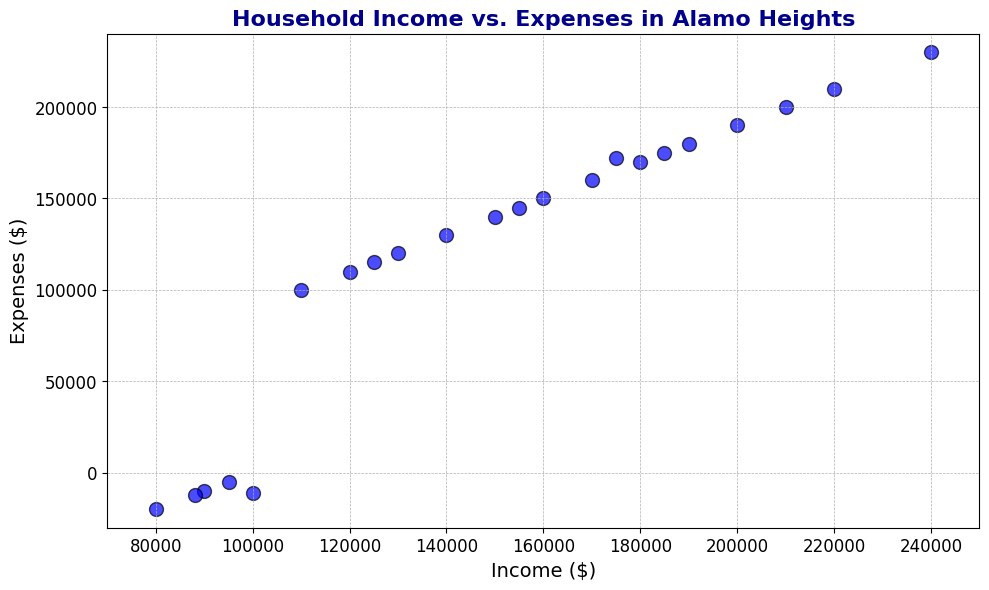What is the highest household income shown in the figure? Locate the data point with the highest value on the x-axis (Income). The largest income shown is at $240,000.
Answer: $240,000 How many data points show negative household expenses? Count the number of points below the x-axis (where Expenses are negative). There are 5 points below the x-axis.
Answer: 5 Which household income has expenses closest to zero? Identify the point closest to the horizontal axis (where Expenses are near zero). The closest point is where Income is $95,000 and Expenses are -$5,000.
Answer: $95,000 What is the average household income of the families with negative expenses? Summing the incomes of families with negative expenses (90,000, 80,000, 95,000, 88,000, 100,000) and dividing by the number of such families (5): (90,000 + 80,000 + 95,000 + 88,000 + 100,000) / 5 = $90,600
Answer: $90,600 Which household income has the highest expenses? Locate the data point with the highest value on the y-axis (Expenses). The highest expenses shown are at $230,000 corresponding to an income of $240,000.
Answer: $240,000 Compare the household incomes and expenses of the family with the highest income and the family with the lowest income. The family with the highest income ($240,000) has expenses of $230,000. The family with the lowest income ($80,000) has expenses of -$20,000.
Answer: $240,000 income/$230,000 expenses vs. $80,000 income/$-20,000 expenses What is the range of expenses for families earning between $150,000 and $180,000? Identify the data points with incomes in the range. The expenses range from $140,000 to $175,000 for incomes between $150,000 and $180,000.
Answer: $140,000 to $175,000 Is there a family with an income of $100,000? If so, what are their expenses? Find the data point where Income is $100,000. The corresponding expenses are -$11,000.
Answer: Yes, -$11,000 What is the total household income and expenses for the families with incomes over $200,000? Sum the incomes (200,000, 210,000, and 240,000) and the expenses (190,000, 200,000, and 230,000) of families with incomes over $200,000: Total income = 200,000 + 210,000 + 240,000 = $650,000. Total expenses = 190,000 + 200,000 + 230,000 = $620,000
Answer: $650,000 income and $620,000 expenses 